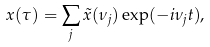Convert formula to latex. <formula><loc_0><loc_0><loc_500><loc_500>x ( \tau ) = \sum _ { j } \tilde { x } ( \nu _ { j } ) \exp ( - i \nu _ { j } t ) ,</formula> 